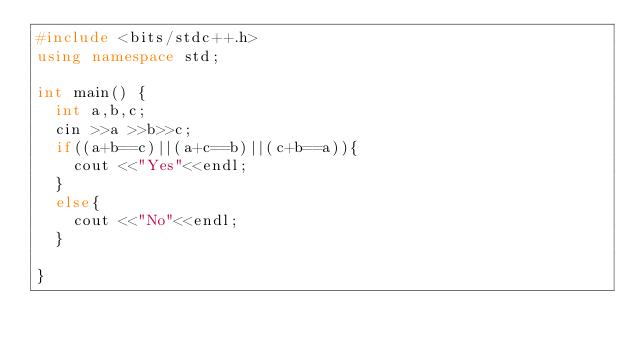<code> <loc_0><loc_0><loc_500><loc_500><_C++_>#include <bits/stdc++.h>
using namespace std;

int main() {
  int a,b,c;
  cin >>a >>b>>c;
  if((a+b==c)||(a+c==b)||(c+b==a)){
    cout <<"Yes"<<endl;
  }
  else{
    cout <<"No"<<endl;
  }
      
}
</code> 